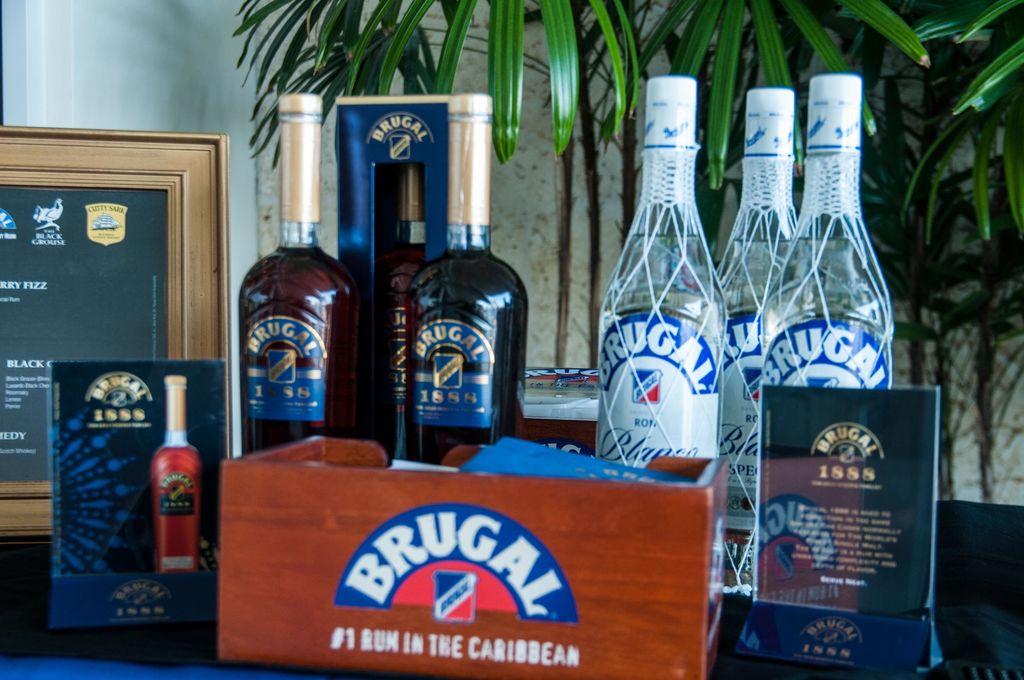What is the rank of brugal ?
Provide a succinct answer. #1. What brand is pictured?
Give a very brief answer. Brugal. 